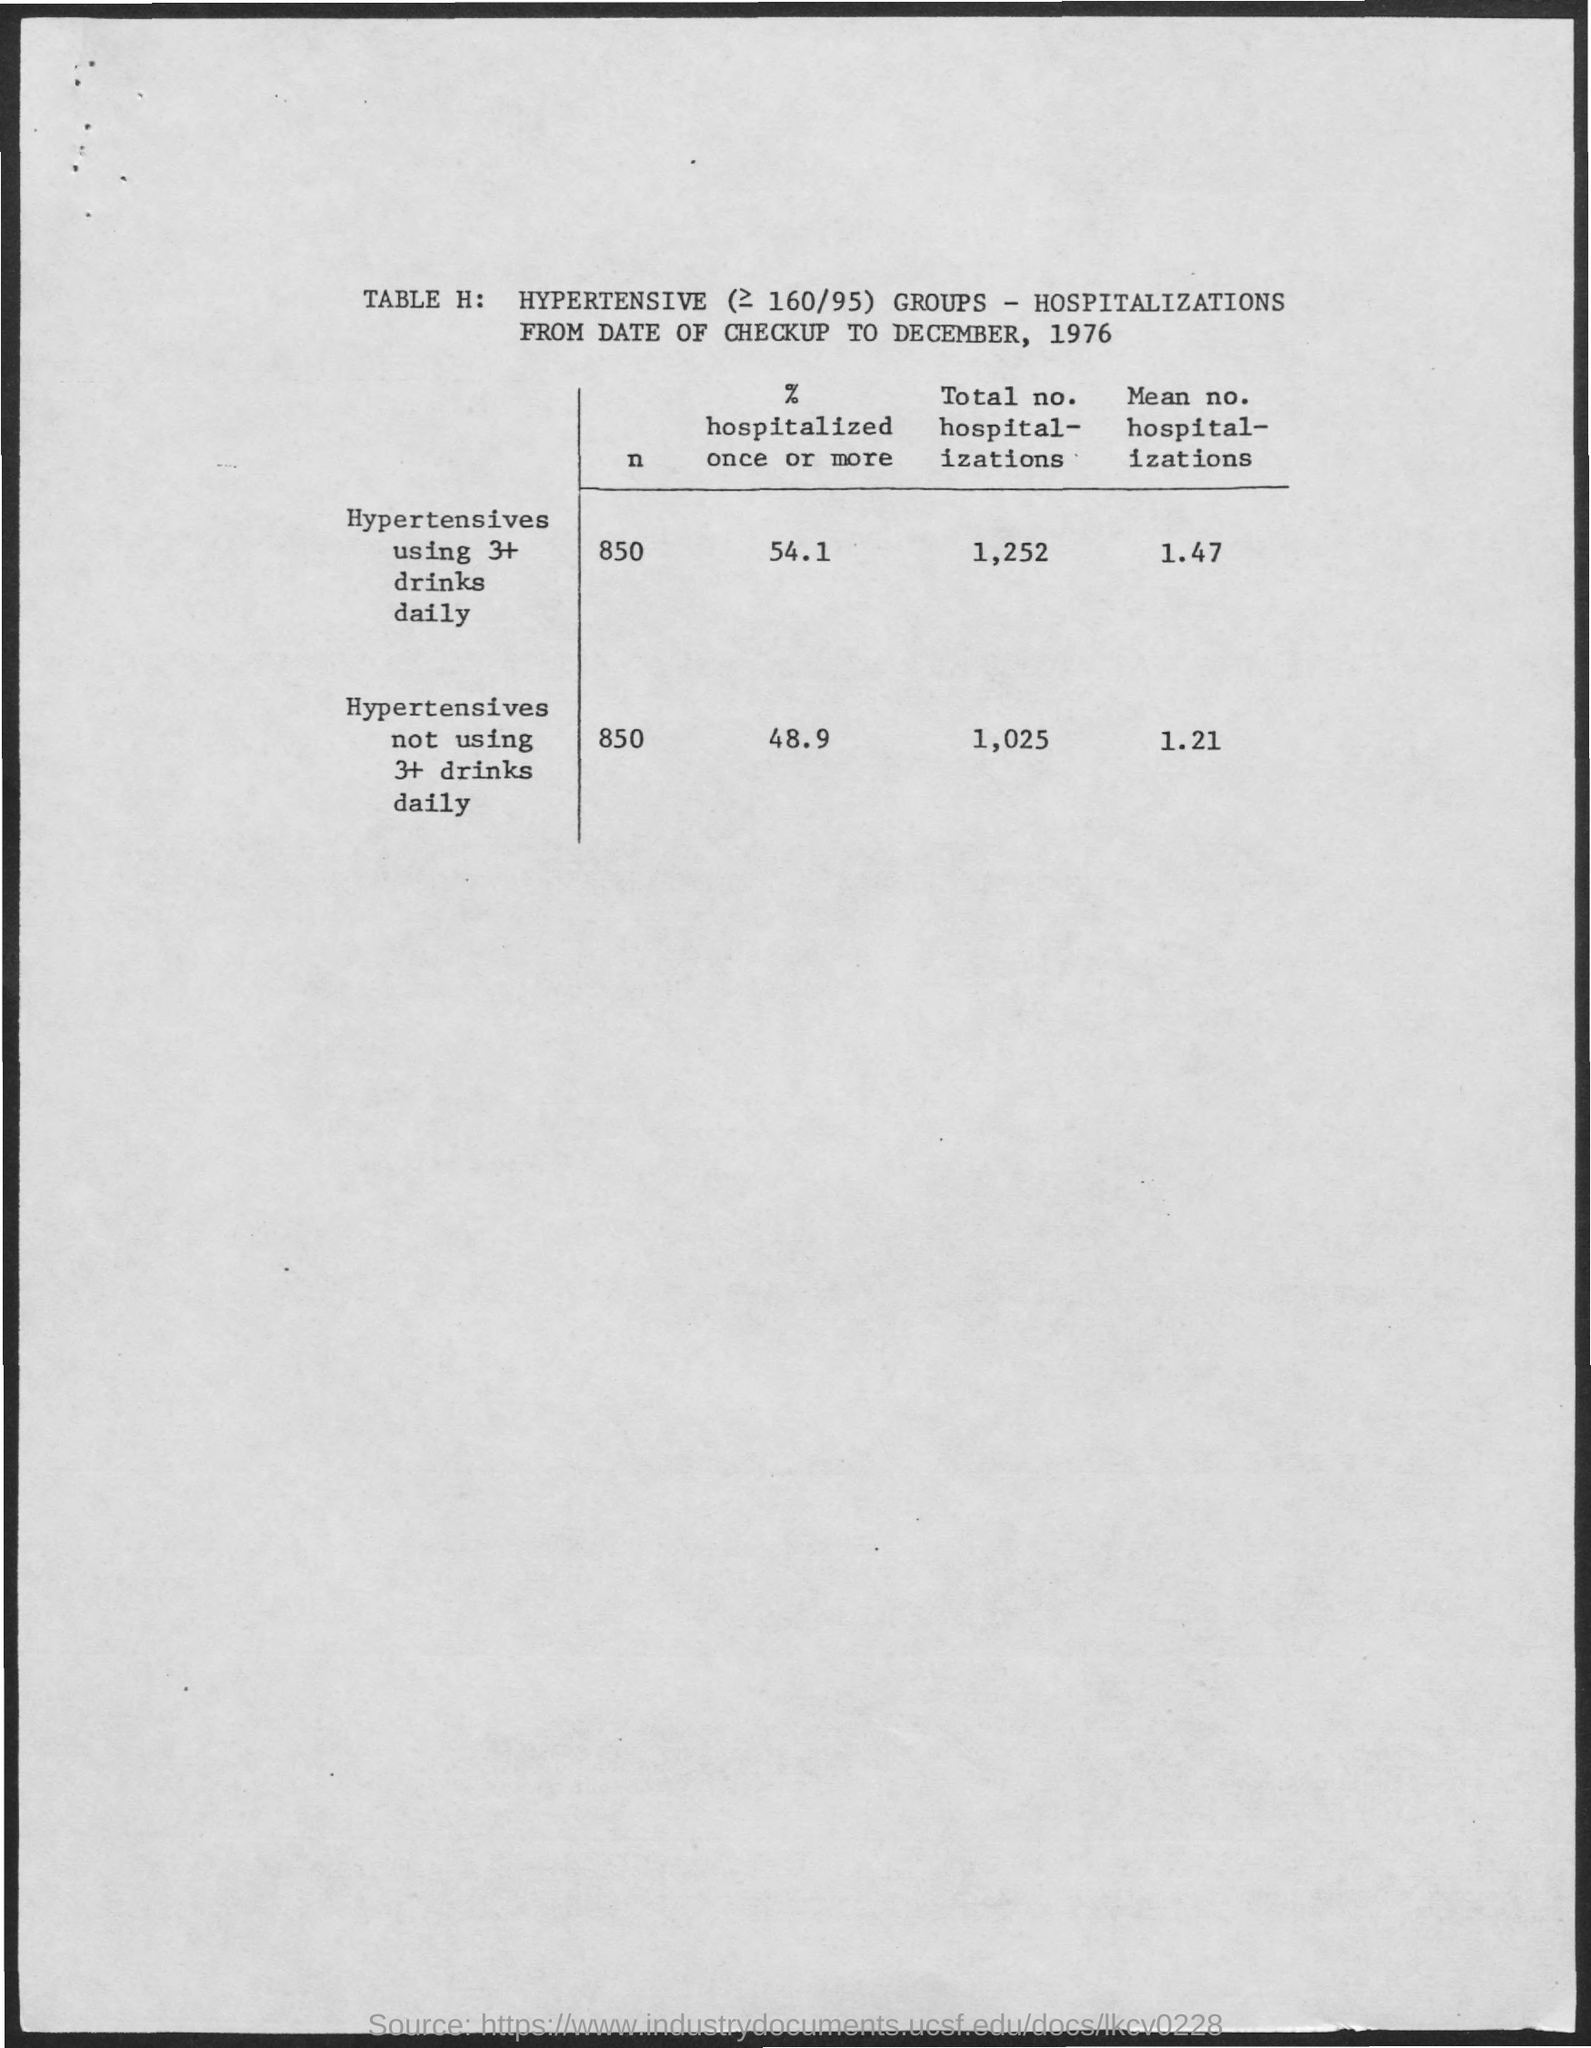Identify some key points in this picture. The value of n for hypertensives who consume 3 or more drinks per day is not yet established. 